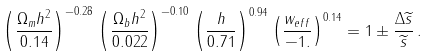Convert formula to latex. <formula><loc_0><loc_0><loc_500><loc_500>\left ( \frac { \Omega _ { m } h ^ { 2 } } { 0 . 1 4 } \right ) ^ { - 0 . 2 8 } \left ( \frac { \Omega _ { b } h ^ { 2 } } { 0 . 0 2 2 } \right ) ^ { - 0 . 1 0 } \left ( \frac { h } { 0 . 7 1 } \right ) ^ { 0 . 9 4 } \left ( \frac { w _ { e f f } } { - 1 . } \right ) ^ { 0 . 1 4 } = 1 \pm \frac { \Delta \widetilde { s } } { \widetilde { s } } \, .</formula> 